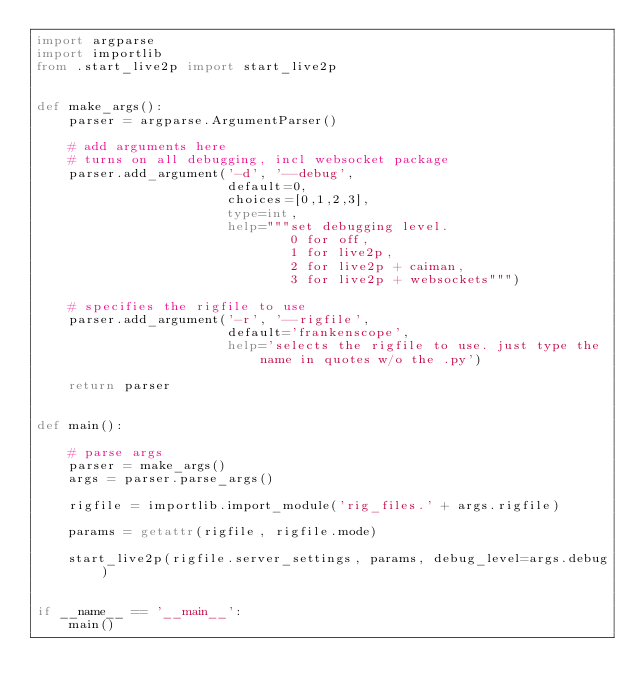<code> <loc_0><loc_0><loc_500><loc_500><_Python_>import argparse
import importlib
from .start_live2p import start_live2p


def make_args():
    parser = argparse.ArgumentParser()
    
    # add arguments here
    # turns on all debugging, incl websocket package
    parser.add_argument('-d', '--debug', 
                        default=0, 
                        choices=[0,1,2,3],
                        type=int,
                        help="""set debugging level. 
                                0 for off, 
                                1 for live2p, 
                                2 for live2p + caiman, 
                                3 for live2p + websockets""")
    
    # specifies the rigfile to use
    parser.add_argument('-r', '--rigfile', 
                        default='frankenscope',
                        help='selects the rigfile to use. just type the name in quotes w/o the .py')
    
    return parser


def main():
    
    # parse args
    parser = make_args()
    args = parser.parse_args()
    
    rigfile = importlib.import_module('rig_files.' + args.rigfile)
    
    params = getattr(rigfile, rigfile.mode)
    
    start_live2p(rigfile.server_settings, params, debug_level=args.debug)

    
if __name__ == '__main__':
    main()</code> 